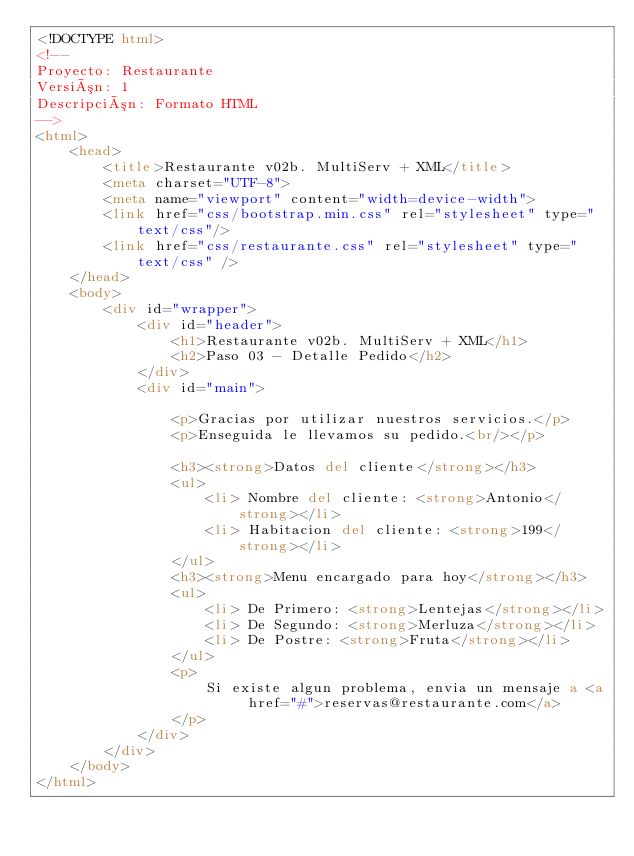<code> <loc_0><loc_0><loc_500><loc_500><_HTML_><!DOCTYPE html>
<!--
Proyecto: Restaurante
Versión: 1
Descripción: Formato HTML
-->
<html>
    <head>
        <title>Restaurante v02b. MultiServ + XML</title>
        <meta charset="UTF-8">
        <meta name="viewport" content="width=device-width">
        <link href="css/bootstrap.min.css" rel="stylesheet" type="text/css"/>    
        <link href="css/restaurante.css" rel="stylesheet" type="text/css" />        
    </head>
    <body>
        <div id="wrapper">
            <div id="header">
                <h1>Restaurante v02b. MultiServ + XML</h1>
                <h2>Paso 03 - Detalle Pedido</h2>
            </div>
            <div id="main">

                <p>Gracias por utilizar nuestros servicios.</p>
                <p>Enseguida le llevamos su pedido.<br/></p>

                <h3><strong>Datos del cliente</strong></h3>
                <ul>
                    <li> Nombre del cliente: <strong>Antonio</strong></li>
                    <li> Habitacion del cliente: <strong>199</strong></li>
                </ul>   
                <h3><strong>Menu encargado para hoy</strong></h3>
                <ul>
                    <li> De Primero: <strong>Lentejas</strong></li>
                    <li> De Segundo: <strong>Merluza</strong></li>
                    <li> De Postre: <strong>Fruta</strong></li>
                </ul>
                <p>
                    Si existe algun problema, envia un mensaje a <a href="#">reservas@restaurante.com</a>
                </p>
            </div>
        </div>
    </body>
</html>
</code> 